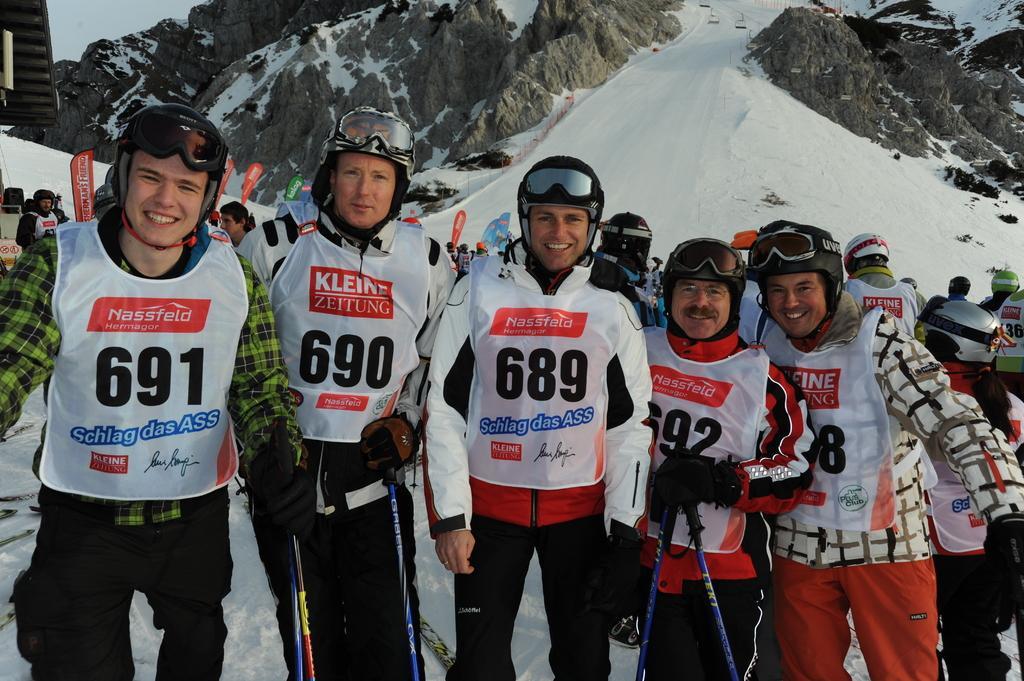Could you give a brief overview of what you see in this image? In this image there are group of people who are standing on the snow and posing for the picture. The group of people are wearing the helmets and spectacles and holding the sticks. In the background there is a snow mountain and there are so many people skiing in the snow. 